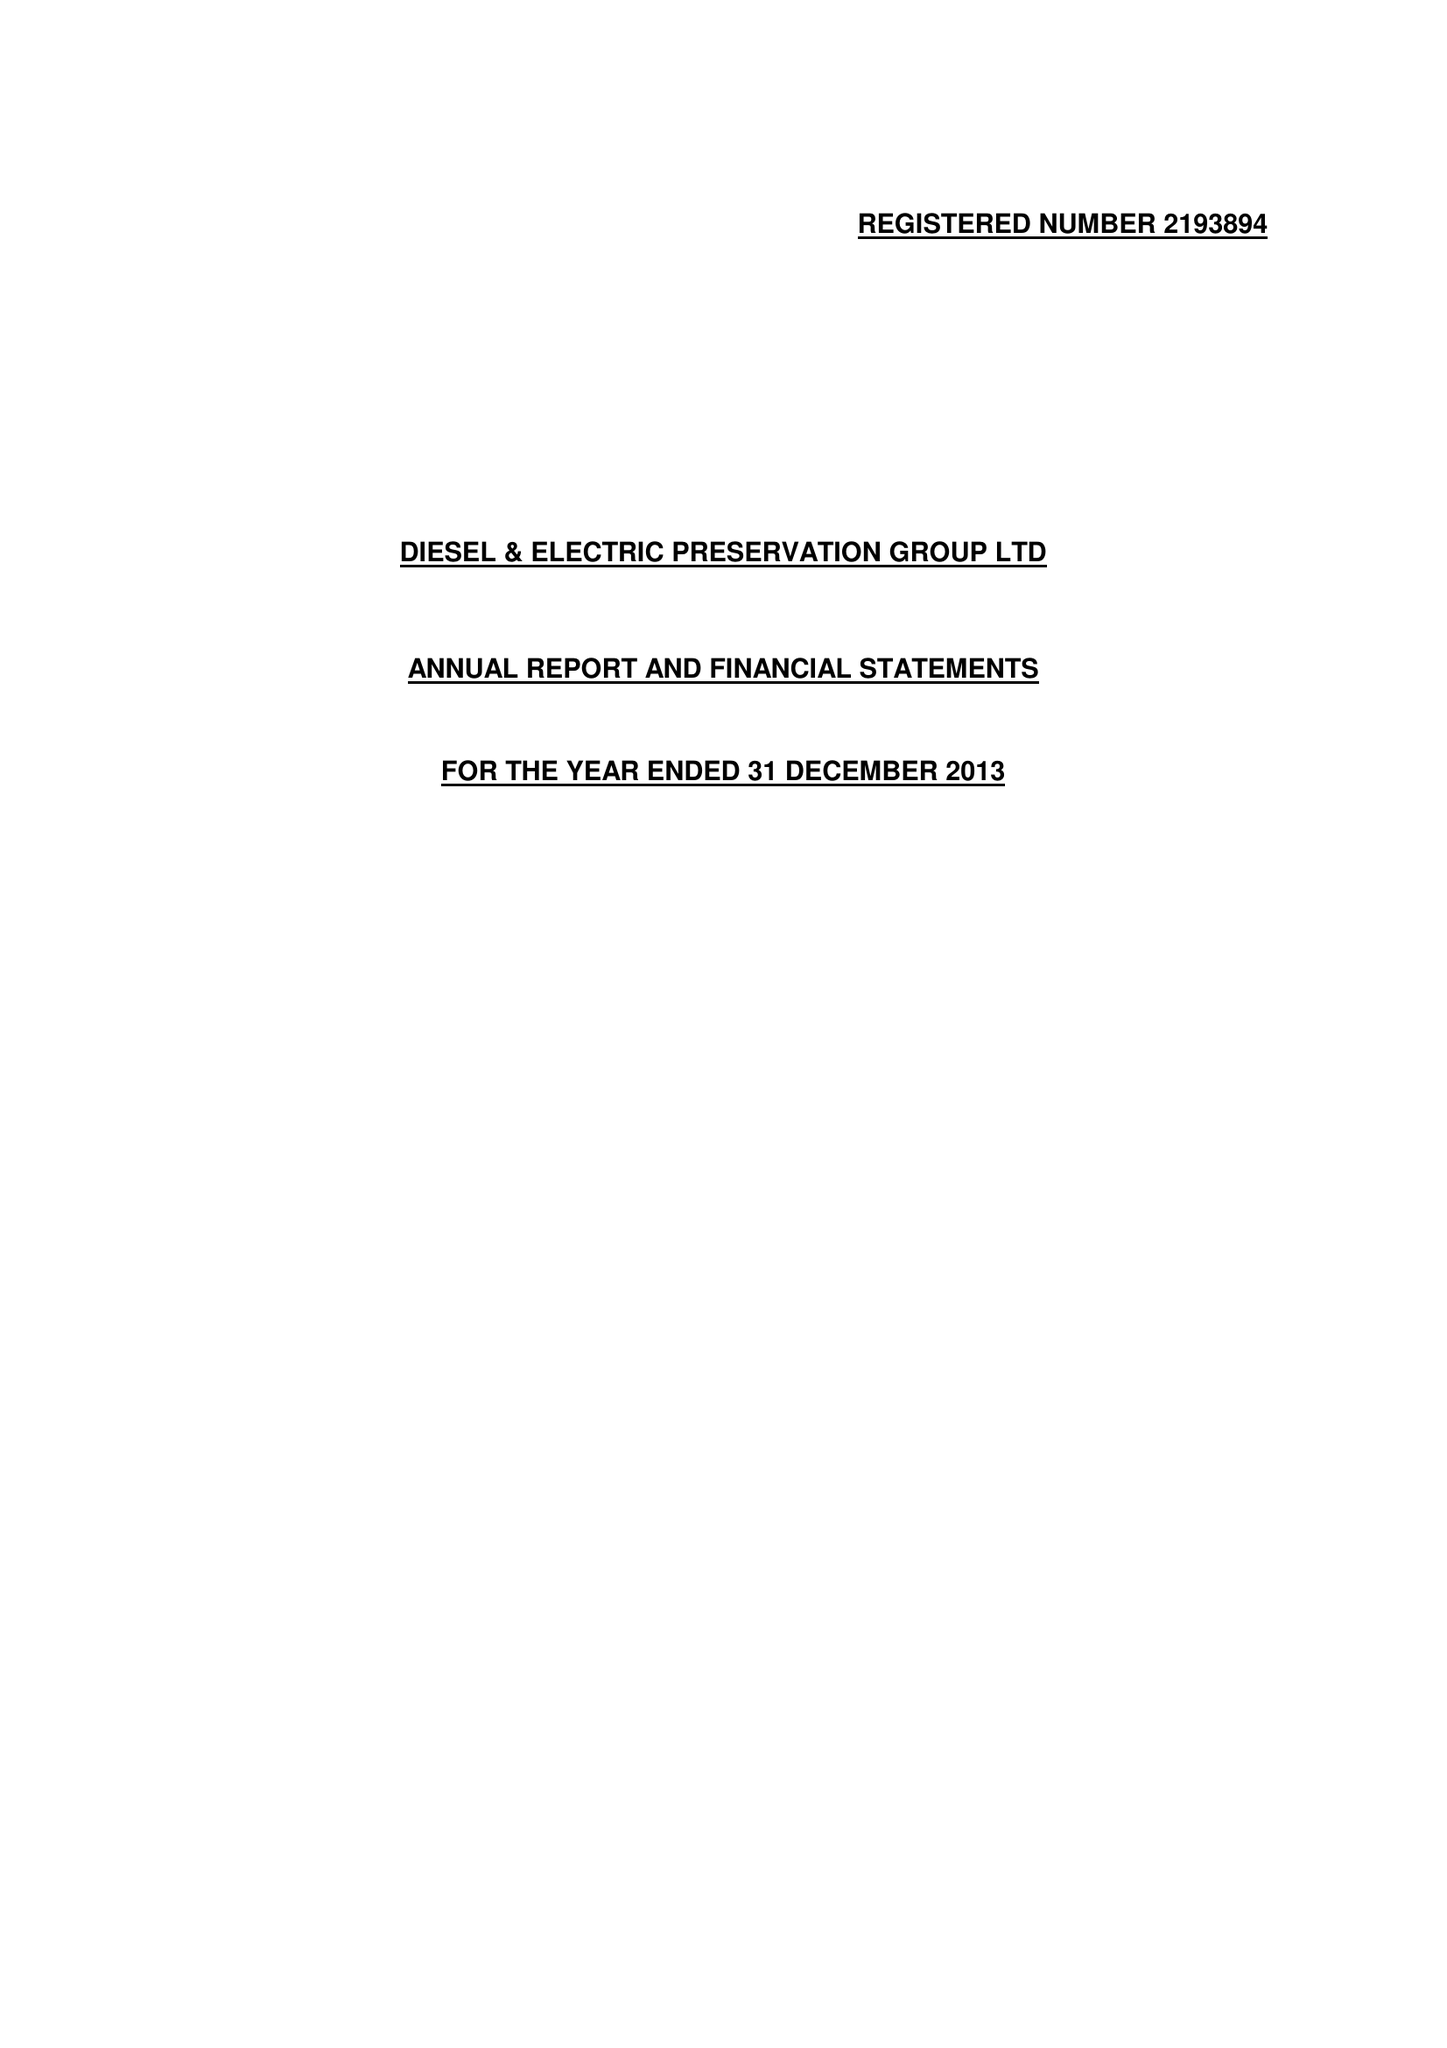What is the value for the income_annually_in_british_pounds?
Answer the question using a single word or phrase. 63132.00 